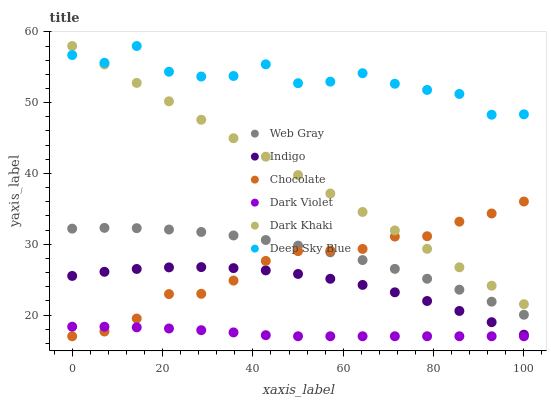Does Dark Violet have the minimum area under the curve?
Answer yes or no. Yes. Does Deep Sky Blue have the maximum area under the curve?
Answer yes or no. Yes. Does Indigo have the minimum area under the curve?
Answer yes or no. No. Does Indigo have the maximum area under the curve?
Answer yes or no. No. Is Dark Khaki the smoothest?
Answer yes or no. Yes. Is Deep Sky Blue the roughest?
Answer yes or no. Yes. Is Indigo the smoothest?
Answer yes or no. No. Is Indigo the roughest?
Answer yes or no. No. Does Dark Violet have the lowest value?
Answer yes or no. Yes. Does Indigo have the lowest value?
Answer yes or no. No. Does Deep Sky Blue have the highest value?
Answer yes or no. Yes. Does Indigo have the highest value?
Answer yes or no. No. Is Indigo less than Dark Khaki?
Answer yes or no. Yes. Is Deep Sky Blue greater than Web Gray?
Answer yes or no. Yes. Does Dark Khaki intersect Deep Sky Blue?
Answer yes or no. Yes. Is Dark Khaki less than Deep Sky Blue?
Answer yes or no. No. Is Dark Khaki greater than Deep Sky Blue?
Answer yes or no. No. Does Indigo intersect Dark Khaki?
Answer yes or no. No. 